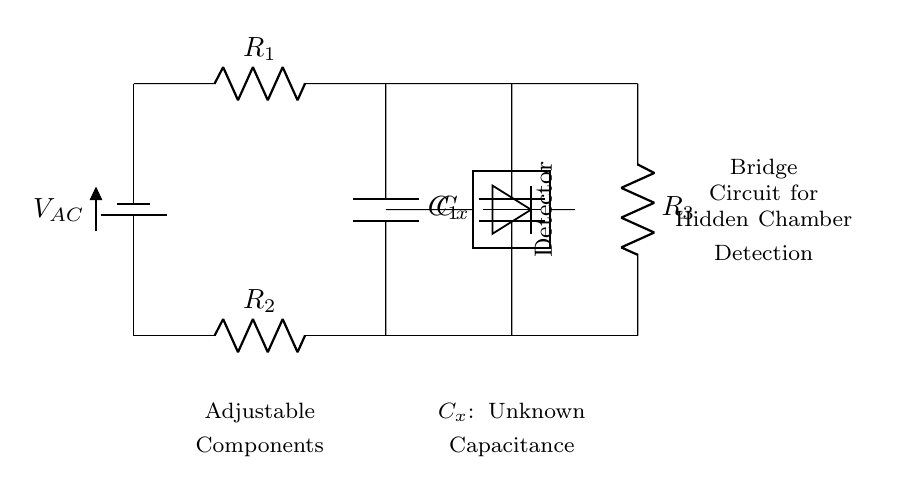What is the type of circuit shown? The circuit is a capacitance bridge circuit, designed to measure unknown capacitance by balancing two branches with known capacitors and resistors.
Answer: capacitance bridge How many resistors are present in the circuit? The circuit has three resistors labeled as R1, R2, and R3, which are part of the bridge configuration.
Answer: three What component is marked as Cx? The component Cx represents the unknown capacitance in the circuit, which is what the capacitance bridge is intended to measure.
Answer: unknown capacitance What is the purpose of the detector in the circuit? The detector is used to sense the balance condition of the bridge, indicating when the unknown capacitance matches the known values.
Answer: sense balance In what configuration are the resistors connected? The resistors R1 and R2 are in series in one arm of the bridge and R3 is in series with the unknown capacitance in the other arm, creating a balanced condition.
Answer: series What does the capacitor labeled C1 do? Capacitor C1 is part of the known component configuration and helps establish the reference point for balancing the bridge with Cx.
Answer: establish reference What happens when the bridge is balanced? When the bridge is balanced, the voltage across the detector becomes zero, indicating that the unknown capacitance matches the known values.
Answer: zero voltage across detector 